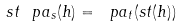<formula> <loc_0><loc_0><loc_500><loc_500>s t \ p a _ { s } ( h ) = \ p a _ { t } ( s t ( h ) )</formula> 